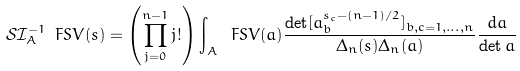<formula> <loc_0><loc_0><loc_500><loc_500>\mathcal { S } \mathcal { I } _ { A } ^ { - 1 } \ F S V ( s ) = \left ( \prod _ { j = 0 } ^ { n - 1 } j ! \right ) \int _ { A } \ F S V ( a ) \frac { \det [ a _ { b } ^ { s _ { c } - ( n - 1 ) / 2 } ] _ { b , c = 1 , \dots , n } } { \Delta _ { n } ( s ) \Delta _ { n } ( a ) } \frac { d a } { \det a }</formula> 